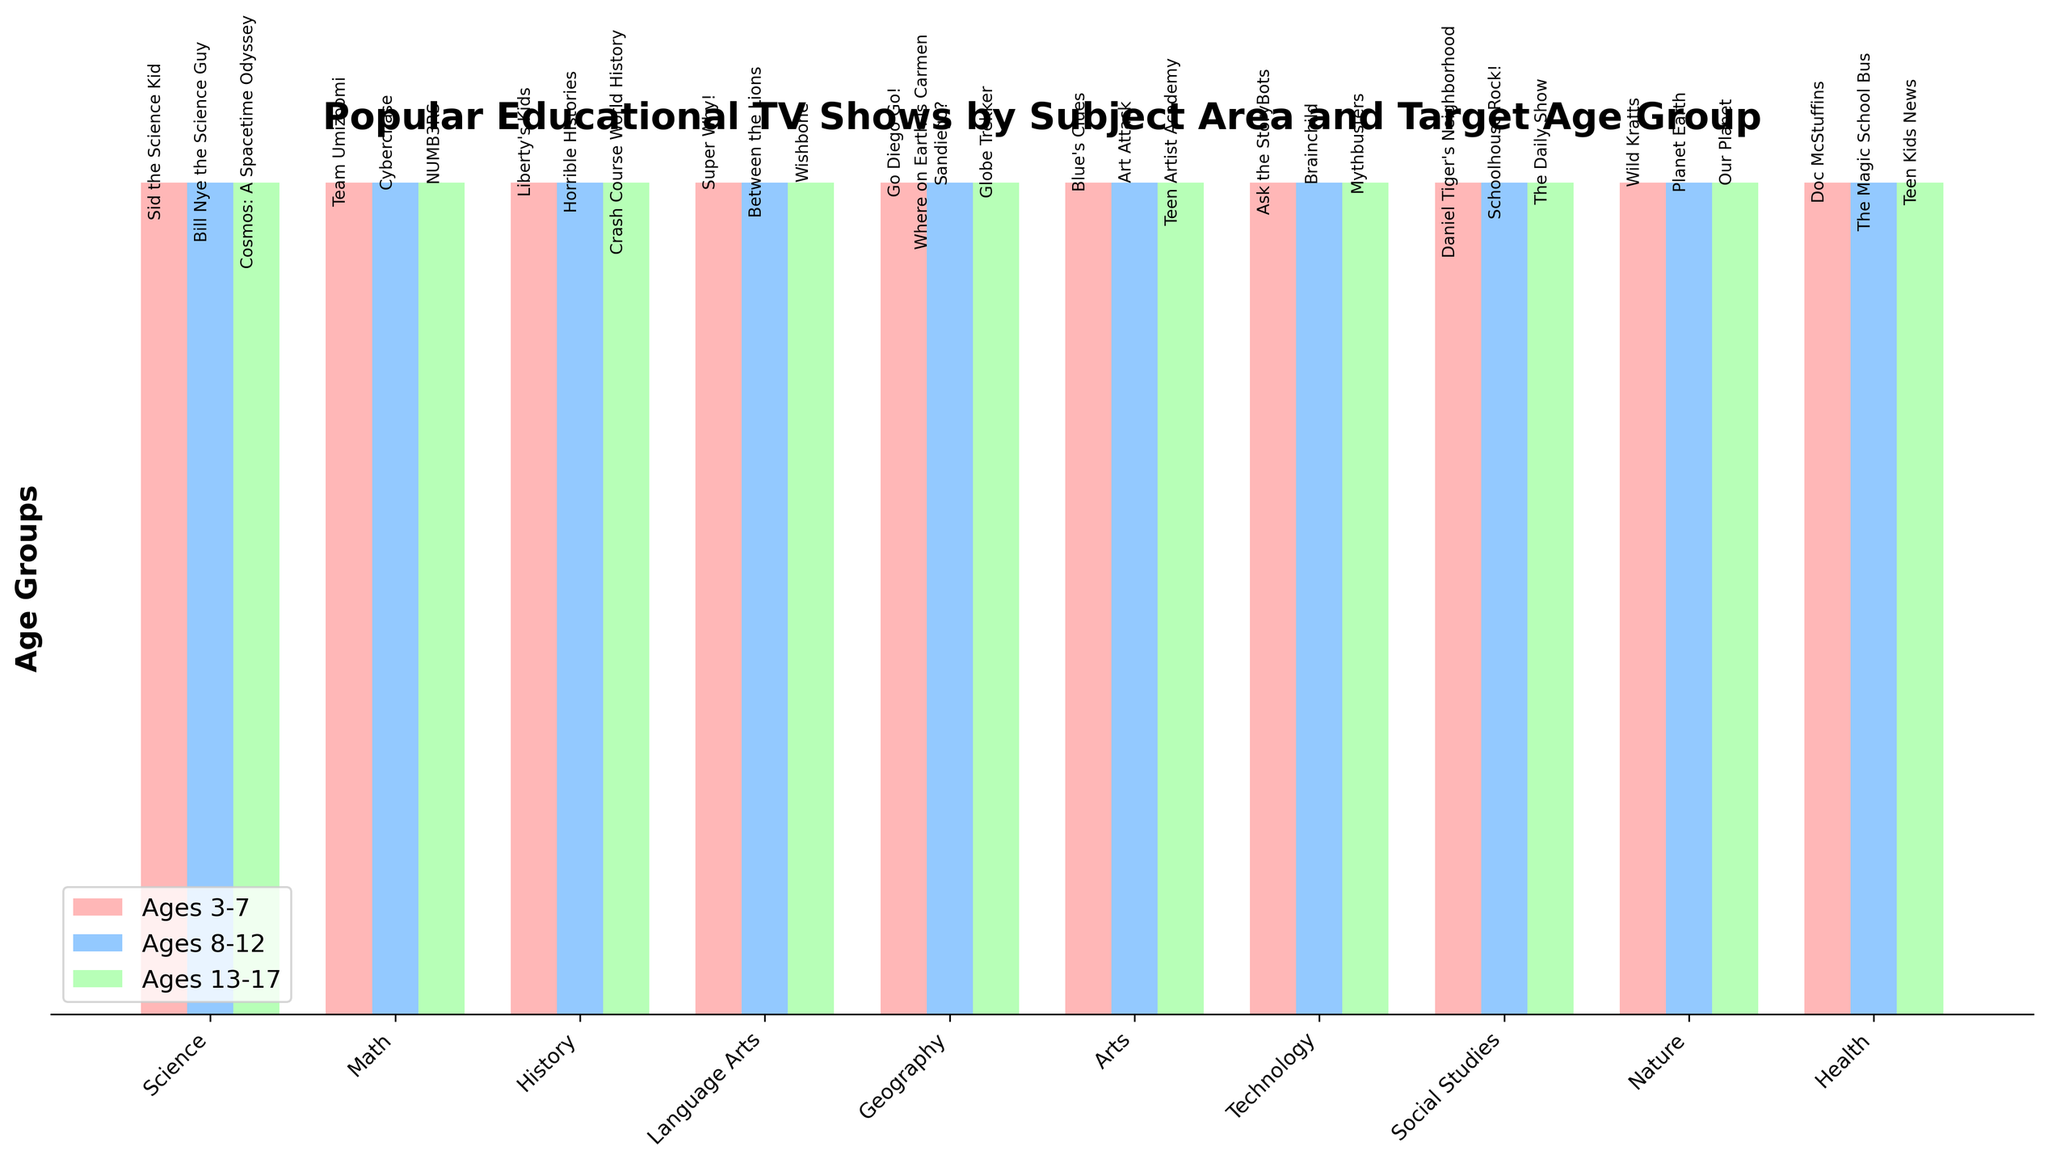Which subject has the educational TV show "Bill Nye the Science Guy" for Ages 8-12? Look at the bar for the subject "Science" under the age group "Ages 8-12". The show listed is "Bill Nye the Science Guy".
Answer: Science What show is recommended for Ages 13-17 under the subject "History"? Examine the bar for "History" under the age group "Ages 13-17". The text over the bar indicates the show is "Crash Course World History".
Answer: Crash Course World History Compare the popularity of "Wild Kratts" and "Planet Earth" in the age group classification. Which age group do these shows target? Identify the age groups across the bar chart. "Wild Kratts" is for "Ages 3-7" and "Planet Earth" is for "Ages 8-12".
Answer: Wild Kratts: 3-7, Planet Earth: 8-12 Which age group bar has the show "Cyberchase" and what subject does it fall under? Find the bar with "Cyberchase" listed. It is under the "Math" subject and "Ages 8-12".
Answer: Ages 8-12, Math List all the educational shows falling under "Social Studies" subject by age group. Check the three age group bars for "Social Studies". The shows listed are "Daniel Tiger's Neighborhood" for Ages 3-7, "Schoolhouse Rock!" for Ages 8-12, and "The Daily Show" for Ages 13-17.
Answer: Ages 3-7: Daniel Tiger's Neighborhood, Ages 8-12: Schoolhouse Rock!, Ages 13-17: The Daily Show How many subjects have a TV show for the "Ages 13-17" group, and what are they? Count the bars under the "Ages 13-17" section. There are 10 subjects: Science, Math, History, Language Arts, Geography, Arts, Technology, Social Studies, Nature, Health.
Answer: 10 subjects Which subject and age group combination lists the show "Doc McStuffins"? Find the bar with "Doc McStuffins". It is under the "Health" subject and "Ages 3-7".
Answer: Health, Ages 3-7 Do the subjects "Art" and "Geography" have the same number of age groups covered? Compare the number of age groups each subject-bar covers. Both "Art" and "Geography" have shows listed for 3 age groups.
Answer: Yes Identify the show in the "Technology" subject for the age group "Ages 8-12". Look at the bar for "Technology" under "Ages 8-12". The show listed is "Brainchild".
Answer: Brainchild Compare the show offerings for the "Language Arts" subject across different age groups. How do they vary? Examine the "Language Arts" bars across all age groups. "Super Why!" for Ages 3-7, "Between the Lions" for Ages 8-12, "Wishbone" for Ages 13-17. They cater to advancing reading skills and literary appreciation.
Answer: Super Why!, Between the Lions, Wishbone 